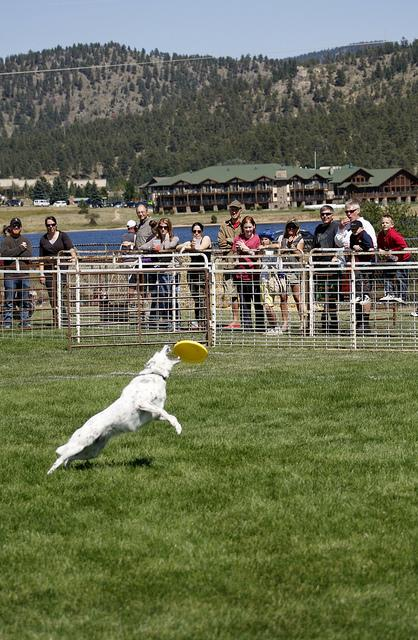Approximately how many people are watching the event?

Choices:
A) hundreds
B) thousands
C) dozen
D) two dozen 